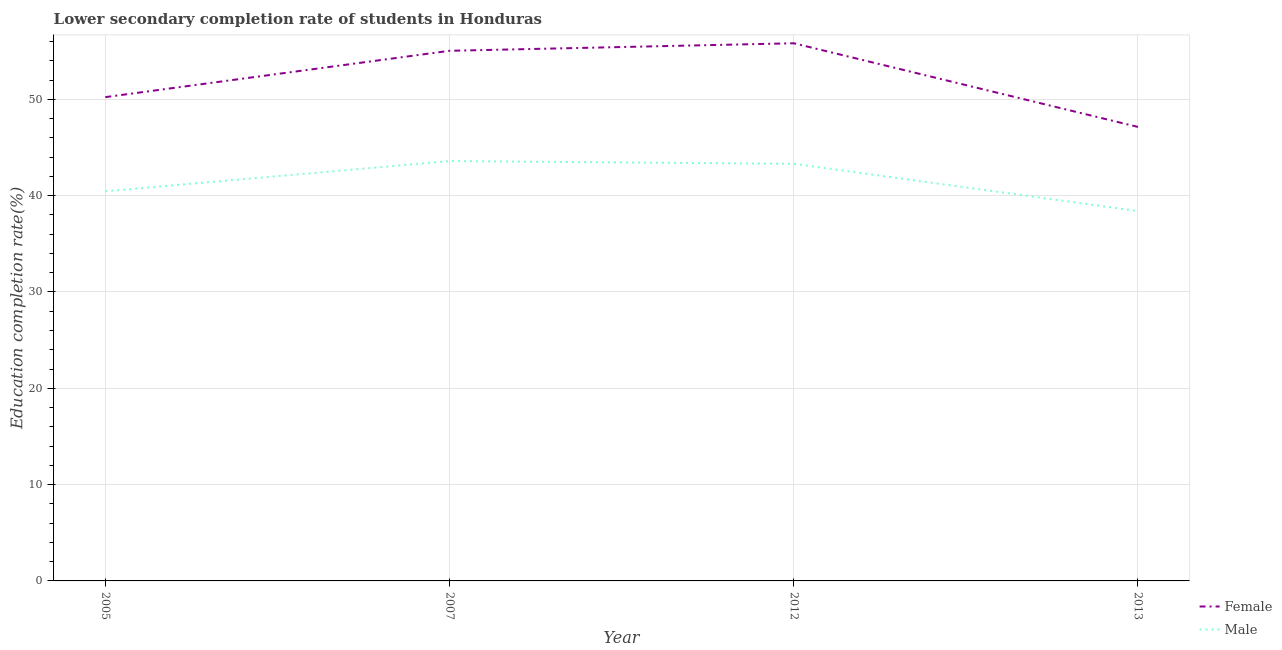How many different coloured lines are there?
Ensure brevity in your answer.  2. Does the line corresponding to education completion rate of female students intersect with the line corresponding to education completion rate of male students?
Provide a succinct answer. No. What is the education completion rate of male students in 2013?
Your answer should be very brief. 38.4. Across all years, what is the maximum education completion rate of female students?
Your answer should be compact. 55.82. Across all years, what is the minimum education completion rate of female students?
Keep it short and to the point. 47.13. What is the total education completion rate of male students in the graph?
Offer a terse response. 165.74. What is the difference between the education completion rate of male students in 2005 and that in 2013?
Keep it short and to the point. 2.05. What is the difference between the education completion rate of female students in 2012 and the education completion rate of male students in 2007?
Provide a succinct answer. 12.23. What is the average education completion rate of female students per year?
Offer a very short reply. 52.05. In the year 2007, what is the difference between the education completion rate of female students and education completion rate of male students?
Make the answer very short. 11.45. In how many years, is the education completion rate of male students greater than 48 %?
Provide a short and direct response. 0. What is the ratio of the education completion rate of male students in 2005 to that in 2007?
Keep it short and to the point. 0.93. Is the education completion rate of male students in 2007 less than that in 2013?
Offer a terse response. No. Is the difference between the education completion rate of male students in 2007 and 2012 greater than the difference between the education completion rate of female students in 2007 and 2012?
Provide a short and direct response. Yes. What is the difference between the highest and the second highest education completion rate of female students?
Provide a short and direct response. 0.78. What is the difference between the highest and the lowest education completion rate of male students?
Make the answer very short. 5.19. Is the sum of the education completion rate of male students in 2005 and 2013 greater than the maximum education completion rate of female students across all years?
Keep it short and to the point. Yes. Does the education completion rate of female students monotonically increase over the years?
Give a very brief answer. No. What is the difference between two consecutive major ticks on the Y-axis?
Provide a short and direct response. 10. Does the graph contain grids?
Your response must be concise. Yes. Where does the legend appear in the graph?
Provide a short and direct response. Bottom right. How are the legend labels stacked?
Make the answer very short. Vertical. What is the title of the graph?
Your answer should be compact. Lower secondary completion rate of students in Honduras. What is the label or title of the Y-axis?
Provide a succinct answer. Education completion rate(%). What is the Education completion rate(%) of Female in 2005?
Ensure brevity in your answer.  50.22. What is the Education completion rate(%) of Male in 2005?
Your answer should be compact. 40.45. What is the Education completion rate(%) of Female in 2007?
Provide a succinct answer. 55.03. What is the Education completion rate(%) in Male in 2007?
Your response must be concise. 43.59. What is the Education completion rate(%) of Female in 2012?
Ensure brevity in your answer.  55.82. What is the Education completion rate(%) of Male in 2012?
Give a very brief answer. 43.3. What is the Education completion rate(%) of Female in 2013?
Provide a short and direct response. 47.13. What is the Education completion rate(%) of Male in 2013?
Provide a short and direct response. 38.4. Across all years, what is the maximum Education completion rate(%) of Female?
Offer a very short reply. 55.82. Across all years, what is the maximum Education completion rate(%) in Male?
Your answer should be very brief. 43.59. Across all years, what is the minimum Education completion rate(%) of Female?
Ensure brevity in your answer.  47.13. Across all years, what is the minimum Education completion rate(%) in Male?
Offer a terse response. 38.4. What is the total Education completion rate(%) in Female in the graph?
Provide a short and direct response. 208.21. What is the total Education completion rate(%) of Male in the graph?
Keep it short and to the point. 165.74. What is the difference between the Education completion rate(%) of Female in 2005 and that in 2007?
Give a very brief answer. -4.81. What is the difference between the Education completion rate(%) of Male in 2005 and that in 2007?
Your answer should be very brief. -3.14. What is the difference between the Education completion rate(%) in Female in 2005 and that in 2012?
Offer a very short reply. -5.59. What is the difference between the Education completion rate(%) in Male in 2005 and that in 2012?
Provide a short and direct response. -2.85. What is the difference between the Education completion rate(%) in Female in 2005 and that in 2013?
Your answer should be very brief. 3.09. What is the difference between the Education completion rate(%) of Male in 2005 and that in 2013?
Your answer should be compact. 2.05. What is the difference between the Education completion rate(%) of Female in 2007 and that in 2012?
Your answer should be very brief. -0.78. What is the difference between the Education completion rate(%) in Male in 2007 and that in 2012?
Give a very brief answer. 0.28. What is the difference between the Education completion rate(%) of Female in 2007 and that in 2013?
Provide a short and direct response. 7.9. What is the difference between the Education completion rate(%) of Male in 2007 and that in 2013?
Your response must be concise. 5.19. What is the difference between the Education completion rate(%) of Female in 2012 and that in 2013?
Ensure brevity in your answer.  8.69. What is the difference between the Education completion rate(%) of Male in 2012 and that in 2013?
Provide a short and direct response. 4.91. What is the difference between the Education completion rate(%) of Female in 2005 and the Education completion rate(%) of Male in 2007?
Your response must be concise. 6.64. What is the difference between the Education completion rate(%) of Female in 2005 and the Education completion rate(%) of Male in 2012?
Make the answer very short. 6.92. What is the difference between the Education completion rate(%) of Female in 2005 and the Education completion rate(%) of Male in 2013?
Offer a terse response. 11.83. What is the difference between the Education completion rate(%) of Female in 2007 and the Education completion rate(%) of Male in 2012?
Offer a very short reply. 11.73. What is the difference between the Education completion rate(%) in Female in 2007 and the Education completion rate(%) in Male in 2013?
Your answer should be very brief. 16.64. What is the difference between the Education completion rate(%) in Female in 2012 and the Education completion rate(%) in Male in 2013?
Provide a short and direct response. 17.42. What is the average Education completion rate(%) of Female per year?
Your response must be concise. 52.05. What is the average Education completion rate(%) of Male per year?
Your answer should be compact. 41.44. In the year 2005, what is the difference between the Education completion rate(%) of Female and Education completion rate(%) of Male?
Provide a short and direct response. 9.77. In the year 2007, what is the difference between the Education completion rate(%) of Female and Education completion rate(%) of Male?
Your answer should be very brief. 11.45. In the year 2012, what is the difference between the Education completion rate(%) of Female and Education completion rate(%) of Male?
Your answer should be compact. 12.51. In the year 2013, what is the difference between the Education completion rate(%) of Female and Education completion rate(%) of Male?
Provide a short and direct response. 8.73. What is the ratio of the Education completion rate(%) in Female in 2005 to that in 2007?
Your answer should be compact. 0.91. What is the ratio of the Education completion rate(%) of Male in 2005 to that in 2007?
Offer a terse response. 0.93. What is the ratio of the Education completion rate(%) of Female in 2005 to that in 2012?
Make the answer very short. 0.9. What is the ratio of the Education completion rate(%) of Male in 2005 to that in 2012?
Offer a terse response. 0.93. What is the ratio of the Education completion rate(%) in Female in 2005 to that in 2013?
Give a very brief answer. 1.07. What is the ratio of the Education completion rate(%) of Male in 2005 to that in 2013?
Your answer should be compact. 1.05. What is the ratio of the Education completion rate(%) of Male in 2007 to that in 2012?
Offer a very short reply. 1.01. What is the ratio of the Education completion rate(%) in Female in 2007 to that in 2013?
Your answer should be very brief. 1.17. What is the ratio of the Education completion rate(%) in Male in 2007 to that in 2013?
Offer a terse response. 1.14. What is the ratio of the Education completion rate(%) in Female in 2012 to that in 2013?
Your answer should be compact. 1.18. What is the ratio of the Education completion rate(%) in Male in 2012 to that in 2013?
Your response must be concise. 1.13. What is the difference between the highest and the second highest Education completion rate(%) in Female?
Offer a very short reply. 0.78. What is the difference between the highest and the second highest Education completion rate(%) of Male?
Ensure brevity in your answer.  0.28. What is the difference between the highest and the lowest Education completion rate(%) of Female?
Provide a succinct answer. 8.69. What is the difference between the highest and the lowest Education completion rate(%) in Male?
Your response must be concise. 5.19. 